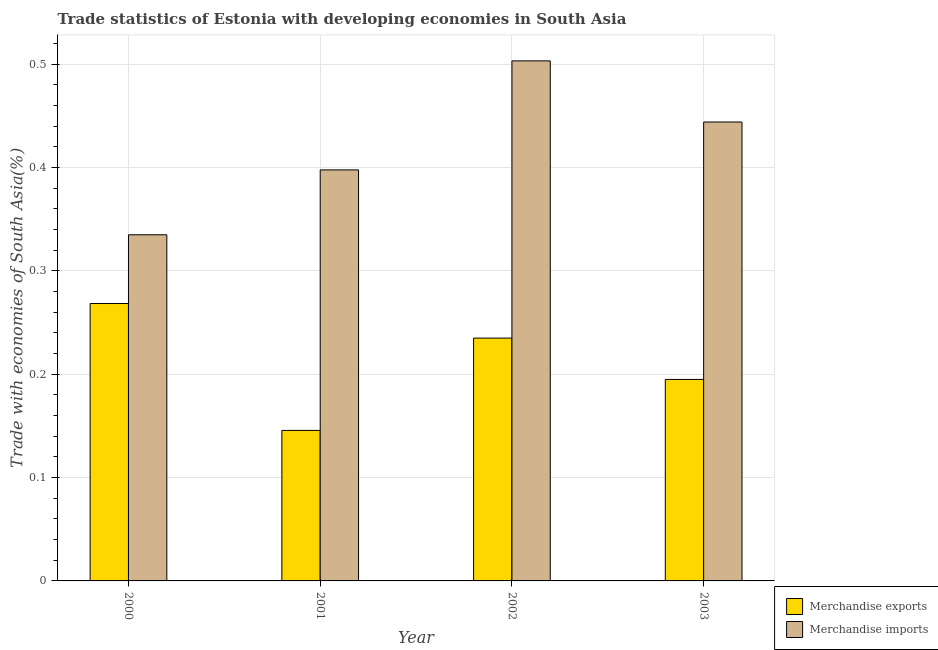How many different coloured bars are there?
Keep it short and to the point. 2. Are the number of bars per tick equal to the number of legend labels?
Your answer should be very brief. Yes. Are the number of bars on each tick of the X-axis equal?
Make the answer very short. Yes. What is the label of the 1st group of bars from the left?
Give a very brief answer. 2000. What is the merchandise imports in 2002?
Offer a terse response. 0.5. Across all years, what is the maximum merchandise exports?
Keep it short and to the point. 0.27. Across all years, what is the minimum merchandise exports?
Your answer should be compact. 0.15. What is the total merchandise exports in the graph?
Offer a terse response. 0.84. What is the difference between the merchandise exports in 2000 and that in 2003?
Ensure brevity in your answer.  0.07. What is the difference between the merchandise imports in 2003 and the merchandise exports in 2001?
Make the answer very short. 0.05. What is the average merchandise exports per year?
Provide a short and direct response. 0.21. In how many years, is the merchandise exports greater than 0.02 %?
Make the answer very short. 4. What is the ratio of the merchandise exports in 2000 to that in 2002?
Your answer should be very brief. 1.14. What is the difference between the highest and the second highest merchandise exports?
Your answer should be very brief. 0.03. What is the difference between the highest and the lowest merchandise imports?
Your response must be concise. 0.17. In how many years, is the merchandise imports greater than the average merchandise imports taken over all years?
Offer a very short reply. 2. Is the sum of the merchandise imports in 2000 and 2003 greater than the maximum merchandise exports across all years?
Make the answer very short. Yes. How many bars are there?
Give a very brief answer. 8. Does the graph contain any zero values?
Give a very brief answer. No. Does the graph contain grids?
Keep it short and to the point. Yes. What is the title of the graph?
Offer a terse response. Trade statistics of Estonia with developing economies in South Asia. Does "Adolescent fertility rate" appear as one of the legend labels in the graph?
Keep it short and to the point. No. What is the label or title of the Y-axis?
Your answer should be very brief. Trade with economies of South Asia(%). What is the Trade with economies of South Asia(%) of Merchandise exports in 2000?
Give a very brief answer. 0.27. What is the Trade with economies of South Asia(%) in Merchandise imports in 2000?
Your answer should be compact. 0.33. What is the Trade with economies of South Asia(%) of Merchandise exports in 2001?
Your answer should be compact. 0.15. What is the Trade with economies of South Asia(%) of Merchandise imports in 2001?
Provide a short and direct response. 0.4. What is the Trade with economies of South Asia(%) in Merchandise exports in 2002?
Offer a terse response. 0.23. What is the Trade with economies of South Asia(%) in Merchandise imports in 2002?
Your response must be concise. 0.5. What is the Trade with economies of South Asia(%) of Merchandise exports in 2003?
Offer a terse response. 0.19. What is the Trade with economies of South Asia(%) in Merchandise imports in 2003?
Keep it short and to the point. 0.44. Across all years, what is the maximum Trade with economies of South Asia(%) in Merchandise exports?
Your answer should be very brief. 0.27. Across all years, what is the maximum Trade with economies of South Asia(%) of Merchandise imports?
Offer a terse response. 0.5. Across all years, what is the minimum Trade with economies of South Asia(%) in Merchandise exports?
Offer a terse response. 0.15. Across all years, what is the minimum Trade with economies of South Asia(%) of Merchandise imports?
Your answer should be compact. 0.33. What is the total Trade with economies of South Asia(%) of Merchandise exports in the graph?
Offer a very short reply. 0.84. What is the total Trade with economies of South Asia(%) in Merchandise imports in the graph?
Provide a succinct answer. 1.68. What is the difference between the Trade with economies of South Asia(%) of Merchandise exports in 2000 and that in 2001?
Offer a terse response. 0.12. What is the difference between the Trade with economies of South Asia(%) of Merchandise imports in 2000 and that in 2001?
Offer a terse response. -0.06. What is the difference between the Trade with economies of South Asia(%) in Merchandise exports in 2000 and that in 2002?
Your answer should be very brief. 0.03. What is the difference between the Trade with economies of South Asia(%) in Merchandise imports in 2000 and that in 2002?
Keep it short and to the point. -0.17. What is the difference between the Trade with economies of South Asia(%) of Merchandise exports in 2000 and that in 2003?
Offer a very short reply. 0.07. What is the difference between the Trade with economies of South Asia(%) of Merchandise imports in 2000 and that in 2003?
Your answer should be very brief. -0.11. What is the difference between the Trade with economies of South Asia(%) of Merchandise exports in 2001 and that in 2002?
Provide a succinct answer. -0.09. What is the difference between the Trade with economies of South Asia(%) of Merchandise imports in 2001 and that in 2002?
Your answer should be compact. -0.11. What is the difference between the Trade with economies of South Asia(%) of Merchandise exports in 2001 and that in 2003?
Give a very brief answer. -0.05. What is the difference between the Trade with economies of South Asia(%) in Merchandise imports in 2001 and that in 2003?
Make the answer very short. -0.05. What is the difference between the Trade with economies of South Asia(%) of Merchandise exports in 2002 and that in 2003?
Your answer should be compact. 0.04. What is the difference between the Trade with economies of South Asia(%) of Merchandise imports in 2002 and that in 2003?
Provide a short and direct response. 0.06. What is the difference between the Trade with economies of South Asia(%) of Merchandise exports in 2000 and the Trade with economies of South Asia(%) of Merchandise imports in 2001?
Your response must be concise. -0.13. What is the difference between the Trade with economies of South Asia(%) of Merchandise exports in 2000 and the Trade with economies of South Asia(%) of Merchandise imports in 2002?
Provide a short and direct response. -0.23. What is the difference between the Trade with economies of South Asia(%) in Merchandise exports in 2000 and the Trade with economies of South Asia(%) in Merchandise imports in 2003?
Offer a very short reply. -0.18. What is the difference between the Trade with economies of South Asia(%) in Merchandise exports in 2001 and the Trade with economies of South Asia(%) in Merchandise imports in 2002?
Your answer should be compact. -0.36. What is the difference between the Trade with economies of South Asia(%) of Merchandise exports in 2001 and the Trade with economies of South Asia(%) of Merchandise imports in 2003?
Make the answer very short. -0.3. What is the difference between the Trade with economies of South Asia(%) of Merchandise exports in 2002 and the Trade with economies of South Asia(%) of Merchandise imports in 2003?
Provide a short and direct response. -0.21. What is the average Trade with economies of South Asia(%) of Merchandise exports per year?
Your response must be concise. 0.21. What is the average Trade with economies of South Asia(%) of Merchandise imports per year?
Keep it short and to the point. 0.42. In the year 2000, what is the difference between the Trade with economies of South Asia(%) of Merchandise exports and Trade with economies of South Asia(%) of Merchandise imports?
Your response must be concise. -0.07. In the year 2001, what is the difference between the Trade with economies of South Asia(%) in Merchandise exports and Trade with economies of South Asia(%) in Merchandise imports?
Make the answer very short. -0.25. In the year 2002, what is the difference between the Trade with economies of South Asia(%) in Merchandise exports and Trade with economies of South Asia(%) in Merchandise imports?
Provide a short and direct response. -0.27. In the year 2003, what is the difference between the Trade with economies of South Asia(%) of Merchandise exports and Trade with economies of South Asia(%) of Merchandise imports?
Ensure brevity in your answer.  -0.25. What is the ratio of the Trade with economies of South Asia(%) in Merchandise exports in 2000 to that in 2001?
Your answer should be very brief. 1.84. What is the ratio of the Trade with economies of South Asia(%) in Merchandise imports in 2000 to that in 2001?
Your response must be concise. 0.84. What is the ratio of the Trade with economies of South Asia(%) in Merchandise exports in 2000 to that in 2002?
Make the answer very short. 1.14. What is the ratio of the Trade with economies of South Asia(%) in Merchandise imports in 2000 to that in 2002?
Offer a terse response. 0.67. What is the ratio of the Trade with economies of South Asia(%) in Merchandise exports in 2000 to that in 2003?
Give a very brief answer. 1.38. What is the ratio of the Trade with economies of South Asia(%) in Merchandise imports in 2000 to that in 2003?
Make the answer very short. 0.75. What is the ratio of the Trade with economies of South Asia(%) in Merchandise exports in 2001 to that in 2002?
Your answer should be compact. 0.62. What is the ratio of the Trade with economies of South Asia(%) of Merchandise imports in 2001 to that in 2002?
Keep it short and to the point. 0.79. What is the ratio of the Trade with economies of South Asia(%) in Merchandise exports in 2001 to that in 2003?
Offer a very short reply. 0.75. What is the ratio of the Trade with economies of South Asia(%) in Merchandise imports in 2001 to that in 2003?
Keep it short and to the point. 0.9. What is the ratio of the Trade with economies of South Asia(%) of Merchandise exports in 2002 to that in 2003?
Ensure brevity in your answer.  1.21. What is the ratio of the Trade with economies of South Asia(%) of Merchandise imports in 2002 to that in 2003?
Provide a short and direct response. 1.13. What is the difference between the highest and the second highest Trade with economies of South Asia(%) of Merchandise exports?
Your answer should be compact. 0.03. What is the difference between the highest and the second highest Trade with economies of South Asia(%) in Merchandise imports?
Provide a short and direct response. 0.06. What is the difference between the highest and the lowest Trade with economies of South Asia(%) in Merchandise exports?
Give a very brief answer. 0.12. What is the difference between the highest and the lowest Trade with economies of South Asia(%) of Merchandise imports?
Offer a very short reply. 0.17. 